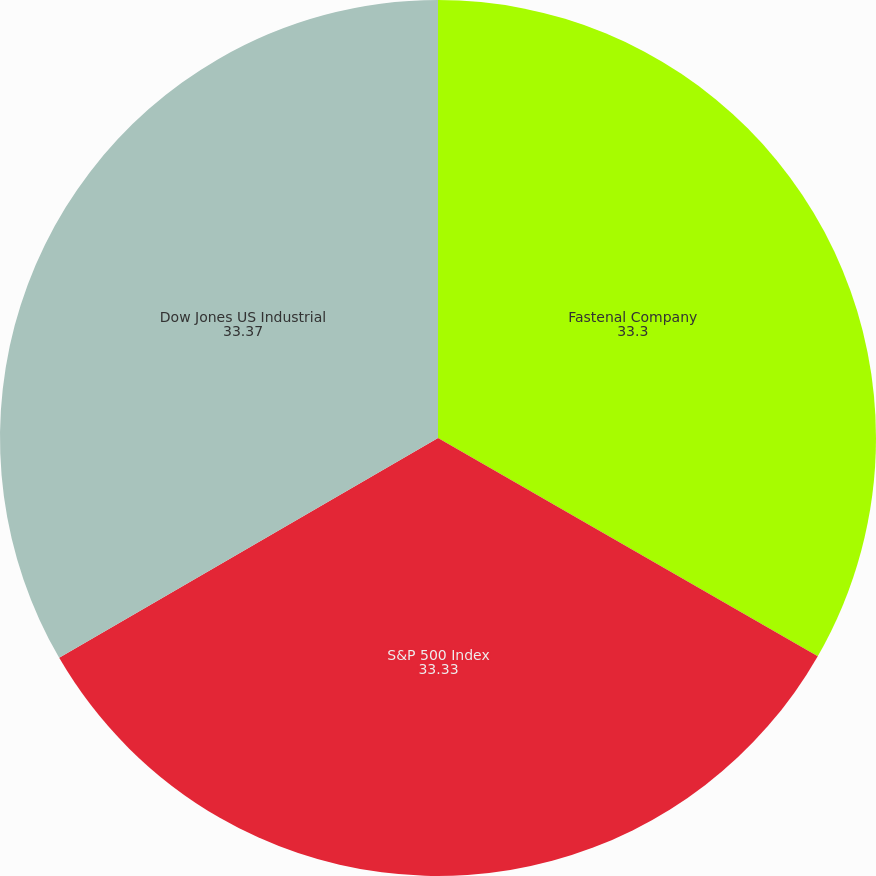Convert chart to OTSL. <chart><loc_0><loc_0><loc_500><loc_500><pie_chart><fcel>Fastenal Company<fcel>S&P 500 Index<fcel>Dow Jones US Industrial<nl><fcel>33.3%<fcel>33.33%<fcel>33.37%<nl></chart> 